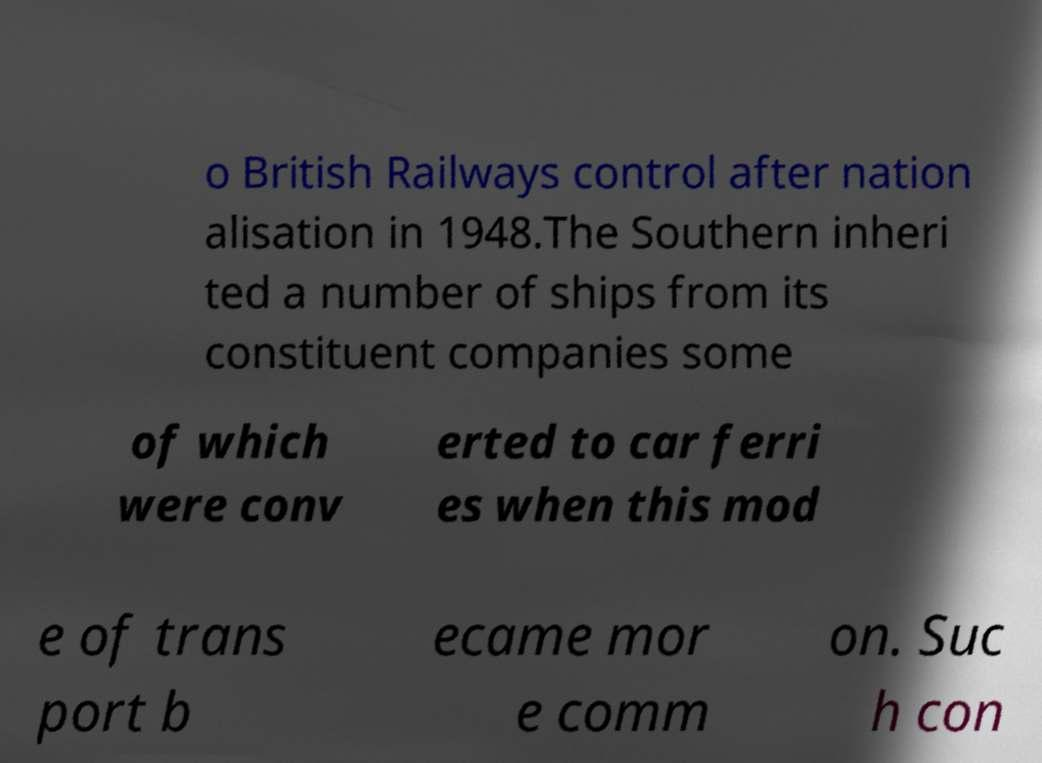Could you extract and type out the text from this image? o British Railways control after nation alisation in 1948.The Southern inheri ted a number of ships from its constituent companies some of which were conv erted to car ferri es when this mod e of trans port b ecame mor e comm on. Suc h con 